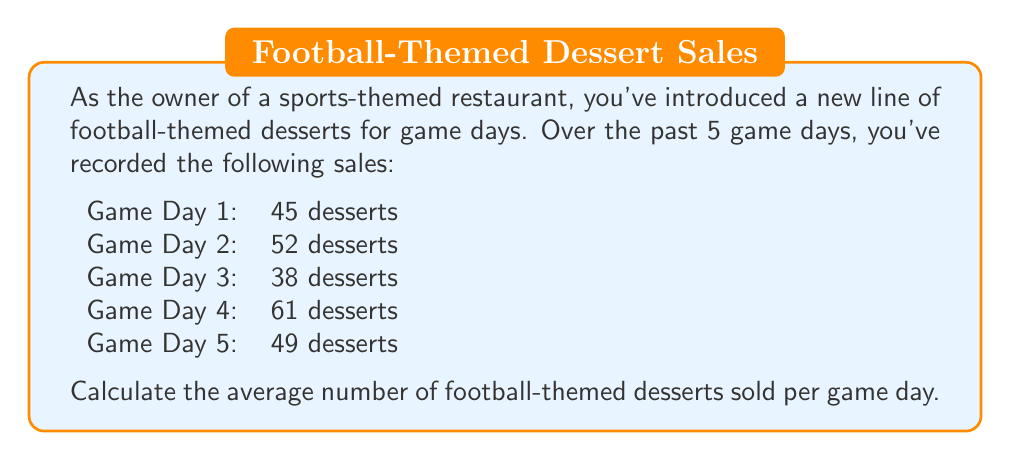Can you solve this math problem? To calculate the average number of desserts sold per game day, we need to follow these steps:

1. Sum up the total number of desserts sold across all game days:
   $$ \text{Total desserts} = 45 + 52 + 38 + 61 + 49 = 245 $$

2. Count the number of game days:
   $$ \text{Number of game days} = 5 $$

3. Calculate the average by dividing the total number of desserts by the number of game days:
   $$ \text{Average} = \frac{\text{Total desserts}}{\text{Number of game days}} = \frac{245}{5} = 49 $$

The formula for calculating the average (arithmetic mean) is:

$$ \bar{x} = \frac{\sum_{i=1}^{n} x_i}{n} $$

Where $\bar{x}$ is the average, $x_i$ are the individual values, and $n$ is the number of values.

In this case:
$$ \bar{x} = \frac{45 + 52 + 38 + 61 + 49}{5} = \frac{245}{5} = 49 $$
Answer: The average number of football-themed desserts sold per game day is 49. 